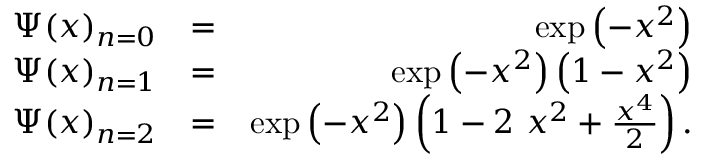Convert formula to latex. <formula><loc_0><loc_0><loc_500><loc_500>\begin{array} { r l r } { \Psi ( x ) _ { n = 0 } } & { = } & { \exp \left ( - x ^ { 2 } \right ) } \\ { \Psi ( x ) _ { n = 1 } } & { = } & { \exp \left ( - x ^ { 2 } \right ) \left ( 1 - x ^ { 2 } \right ) } \\ { \Psi ( x ) _ { n = 2 } } & { = } & { \exp \left ( - x ^ { 2 } \right ) \left ( 1 - 2 x ^ { 2 } + \frac { x ^ { 4 } } { 2 } \right ) . } \end{array}</formula> 